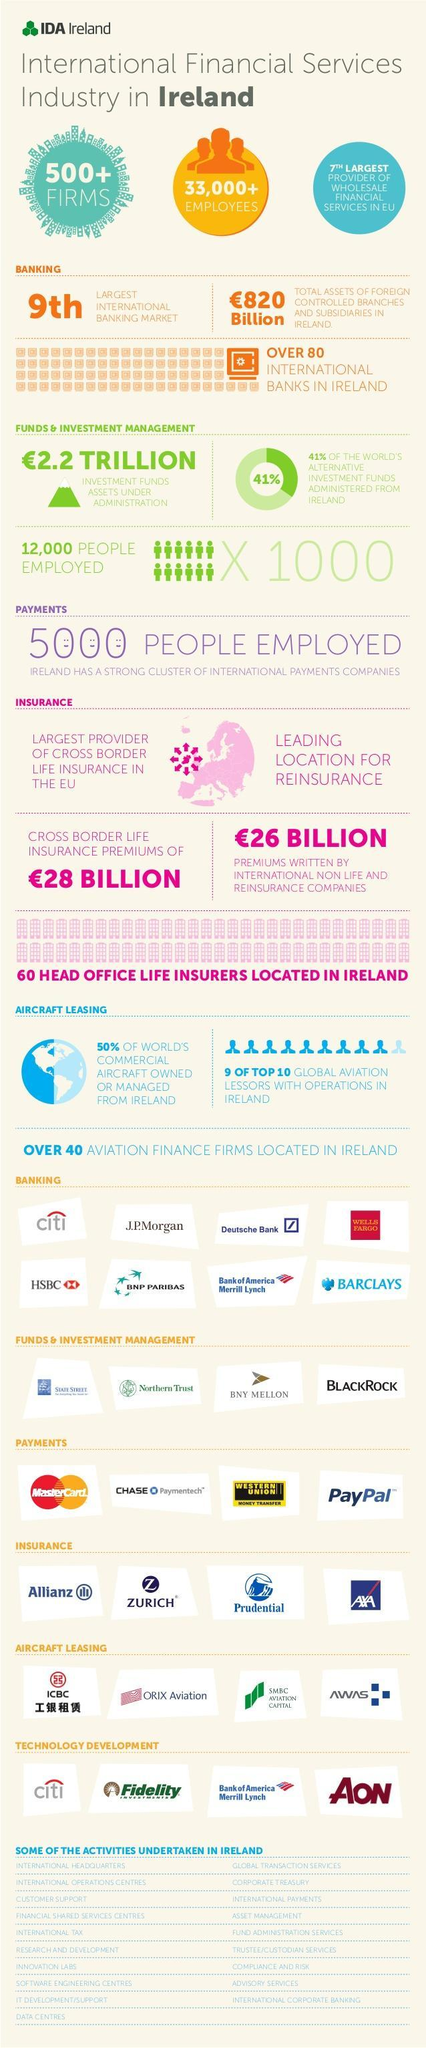How many employees are working in the International Financial Services in Ireland?
Answer the question with a short phrase. 33,000+ 